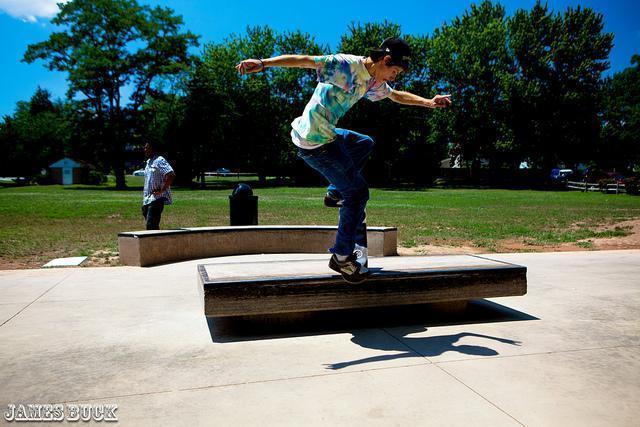In which space is this person boarding?
From the following four choices, select the correct answer to address the question.
Options: Inner city, tundra, park, desert. Park. 